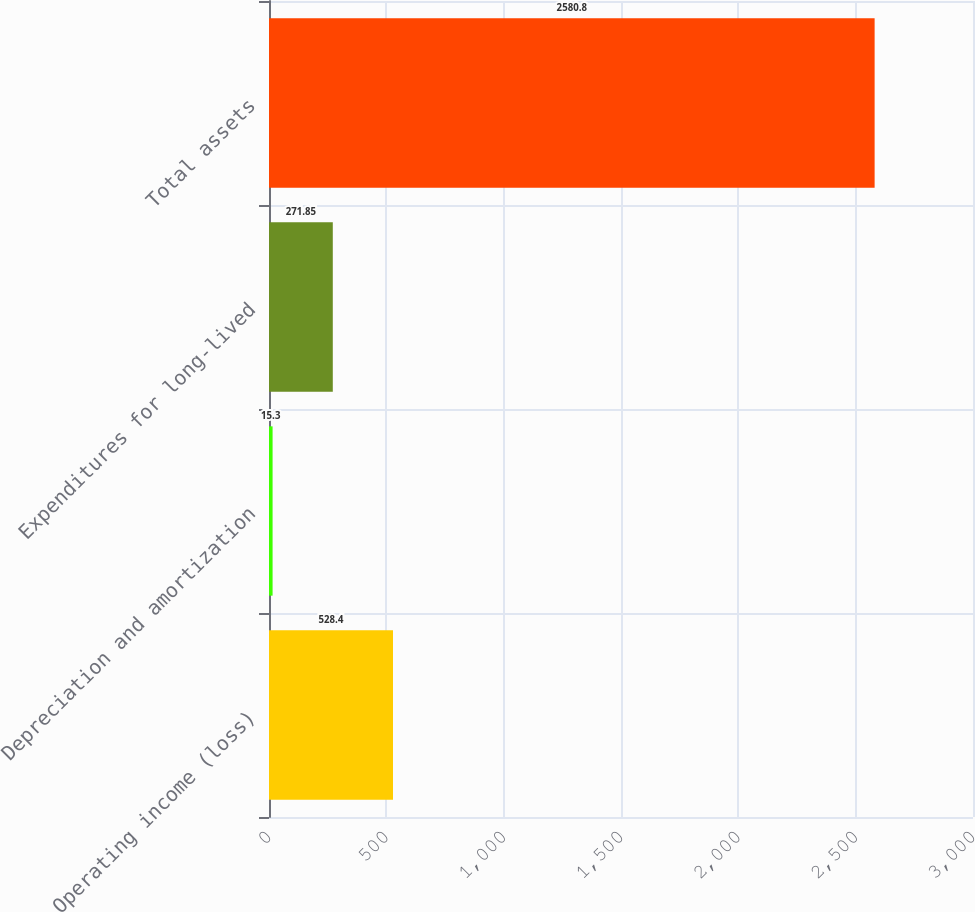Convert chart to OTSL. <chart><loc_0><loc_0><loc_500><loc_500><bar_chart><fcel>Operating income (loss)<fcel>Depreciation and amortization<fcel>Expenditures for long-lived<fcel>Total assets<nl><fcel>528.4<fcel>15.3<fcel>271.85<fcel>2580.8<nl></chart> 